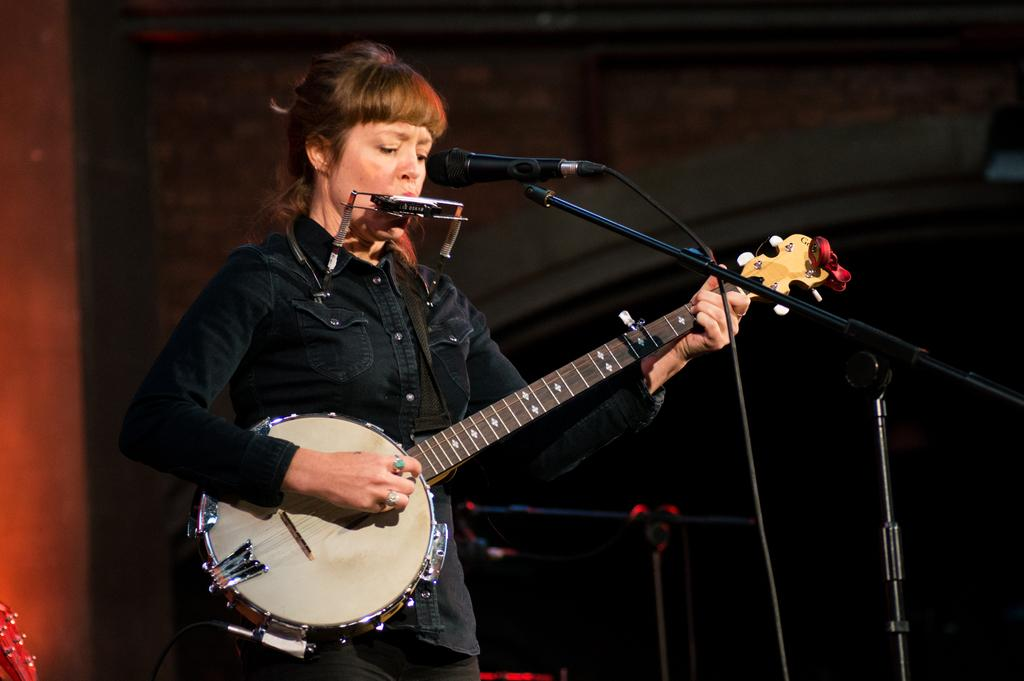Who is the main subject in the image? There is a woman in the image. What is the woman doing in the image? The woman is standing and playing a musical instrument. What object is present in the image that is used for amplifying sound? There is a microphone in the image. What object is present in the image that is used for holding the musical instrument? There is a stand in the image. What type of snow can be seen falling in the image? There is no snow present in the image. How does the plane affect the woman's performance in the image? There is no plane present in the image, so it does not affect the woman's performance. 